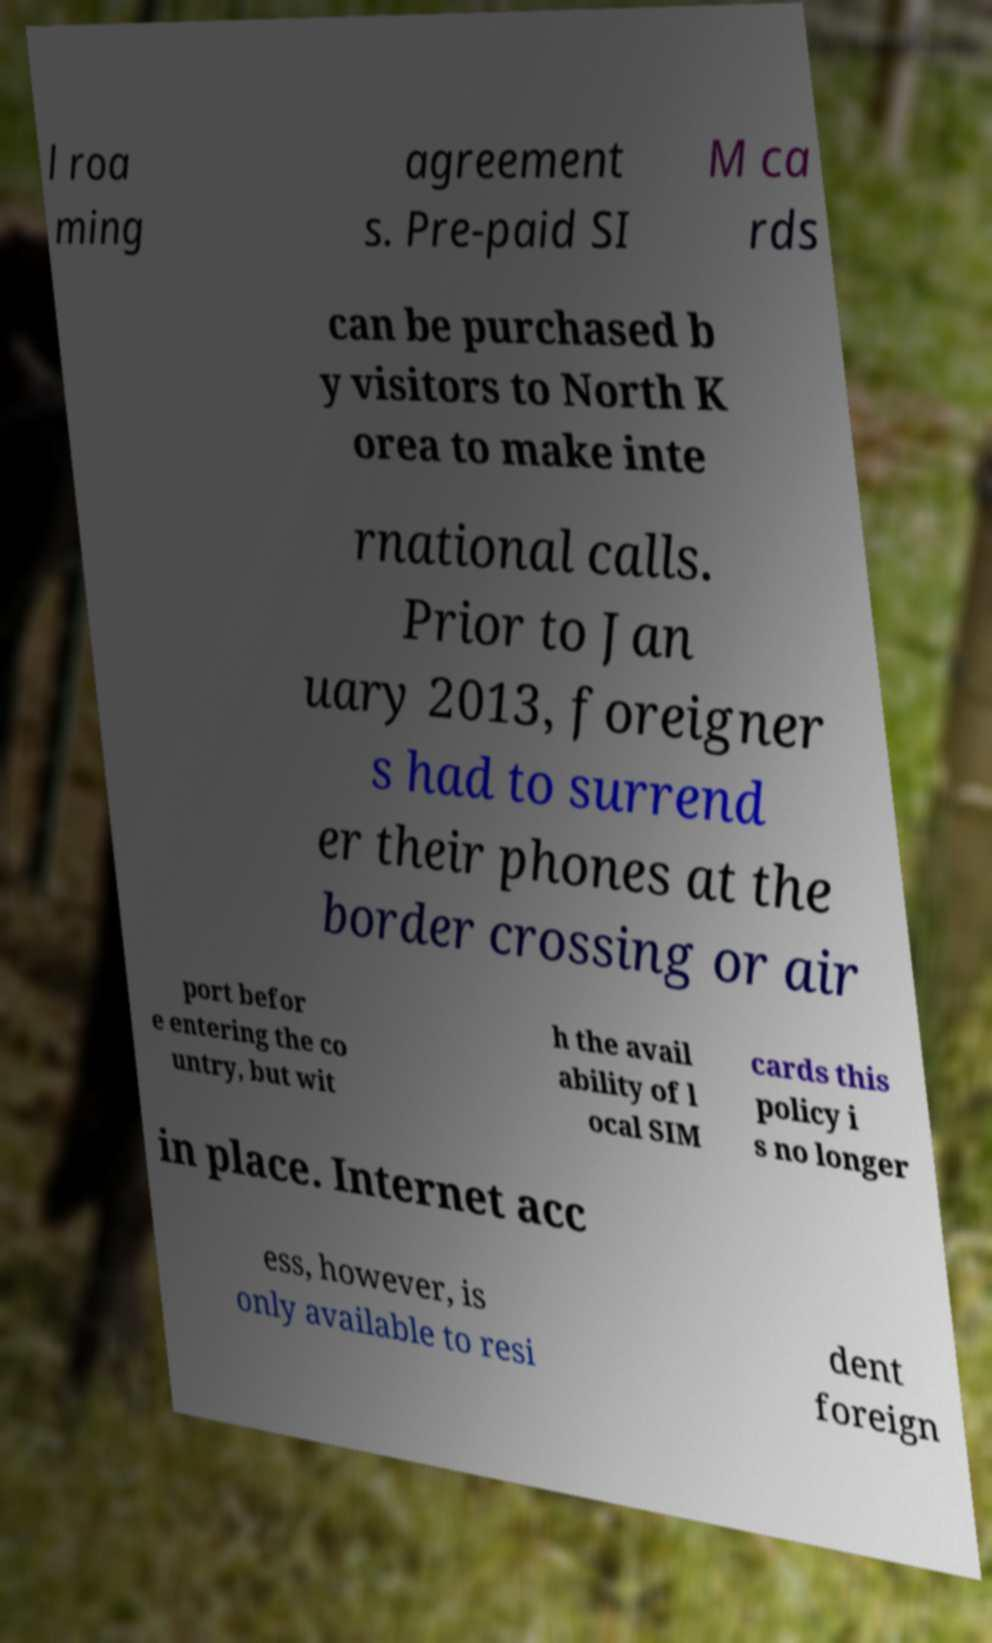What messages or text are displayed in this image? I need them in a readable, typed format. l roa ming agreement s. Pre-paid SI M ca rds can be purchased b y visitors to North K orea to make inte rnational calls. Prior to Jan uary 2013, foreigner s had to surrend er their phones at the border crossing or air port befor e entering the co untry, but wit h the avail ability of l ocal SIM cards this policy i s no longer in place. Internet acc ess, however, is only available to resi dent foreign 